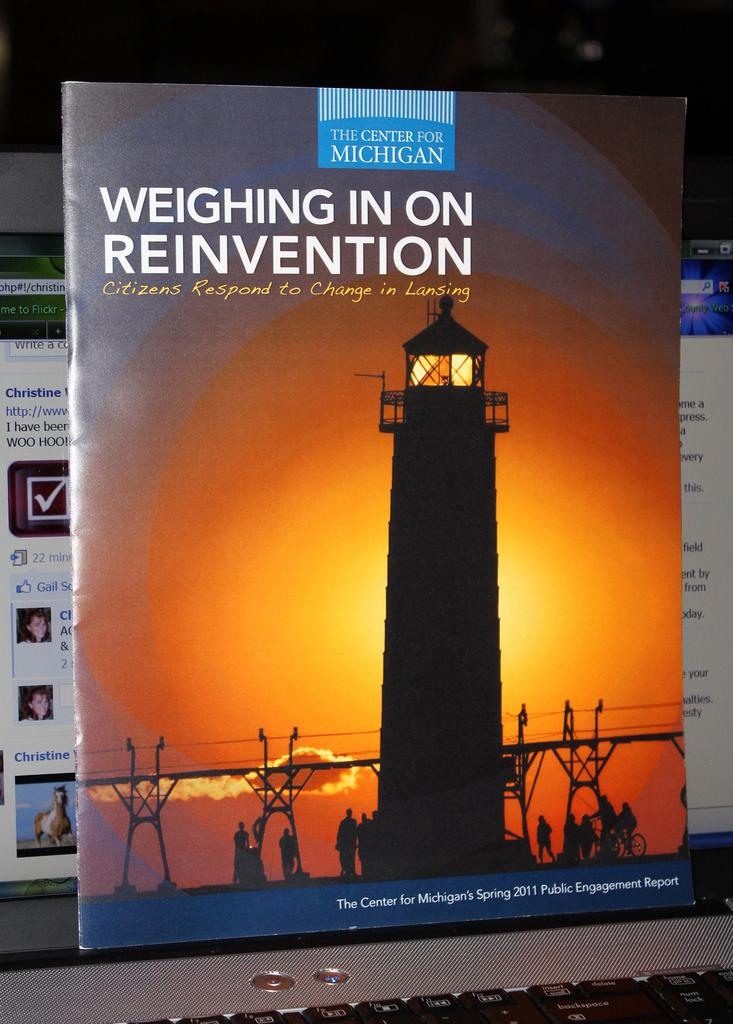<image>
Offer a succinct explanation of the picture presented. A large book titled Weighing in on Reinvention. 